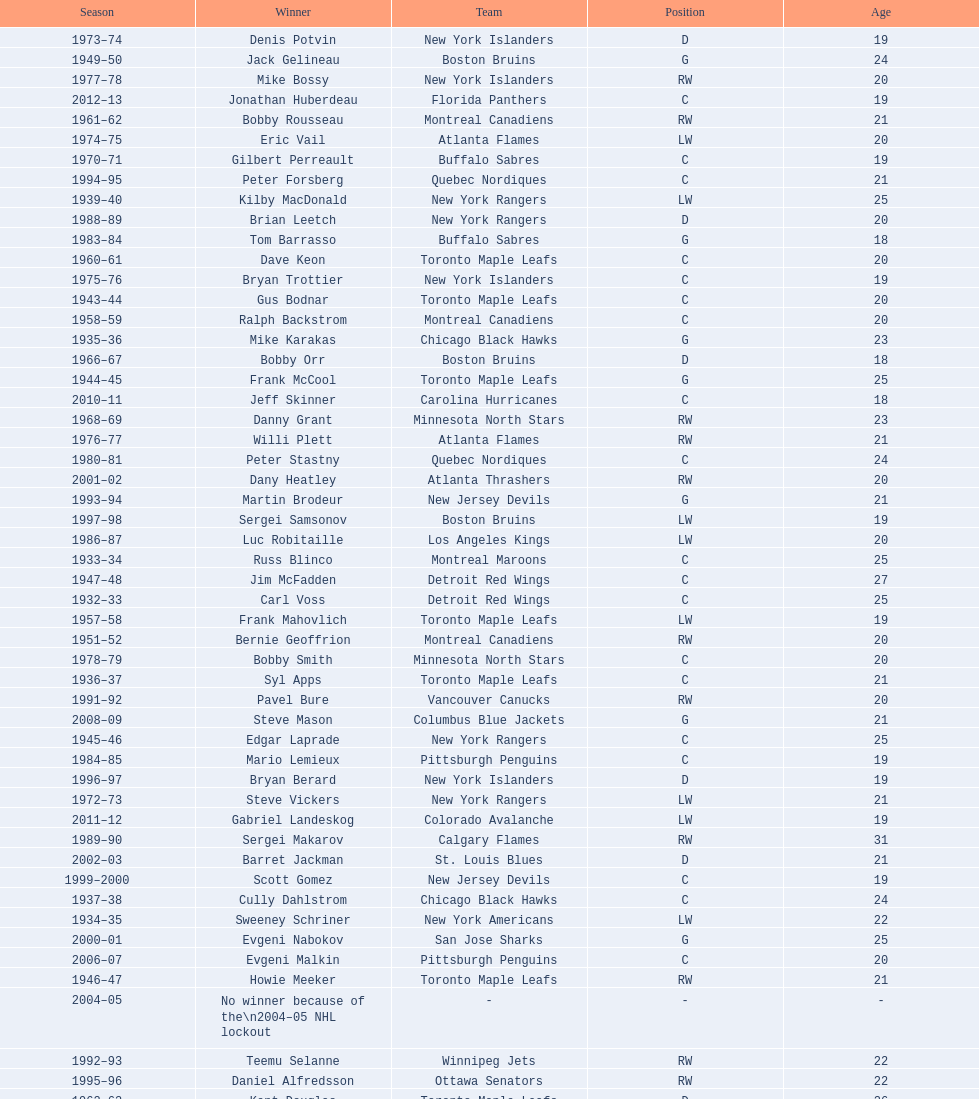Which team has the highest number of consecutive calder memorial trophy winners? Toronto Maple Leafs. 